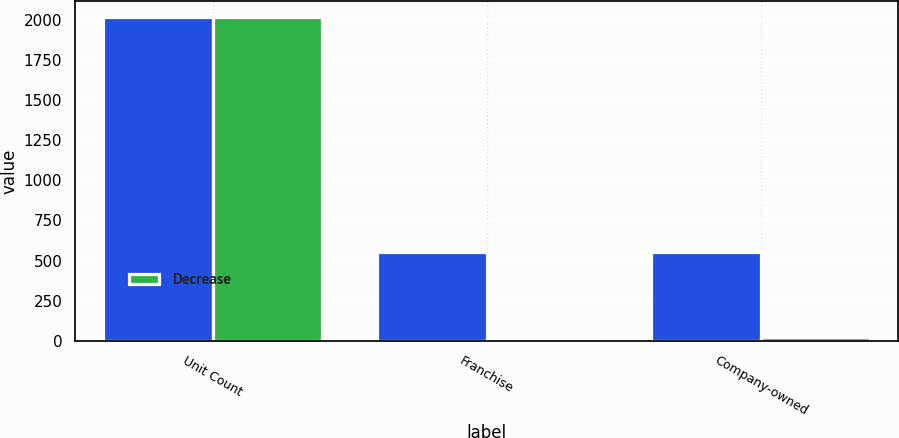<chart> <loc_0><loc_0><loc_500><loc_500><stacked_bar_chart><ecel><fcel>Unit Count<fcel>Franchise<fcel>Company-owned<nl><fcel>nan<fcel>2016<fcel>553<fcel>553<nl><fcel>Decrease<fcel>2016<fcel>4<fcel>27<nl></chart> 